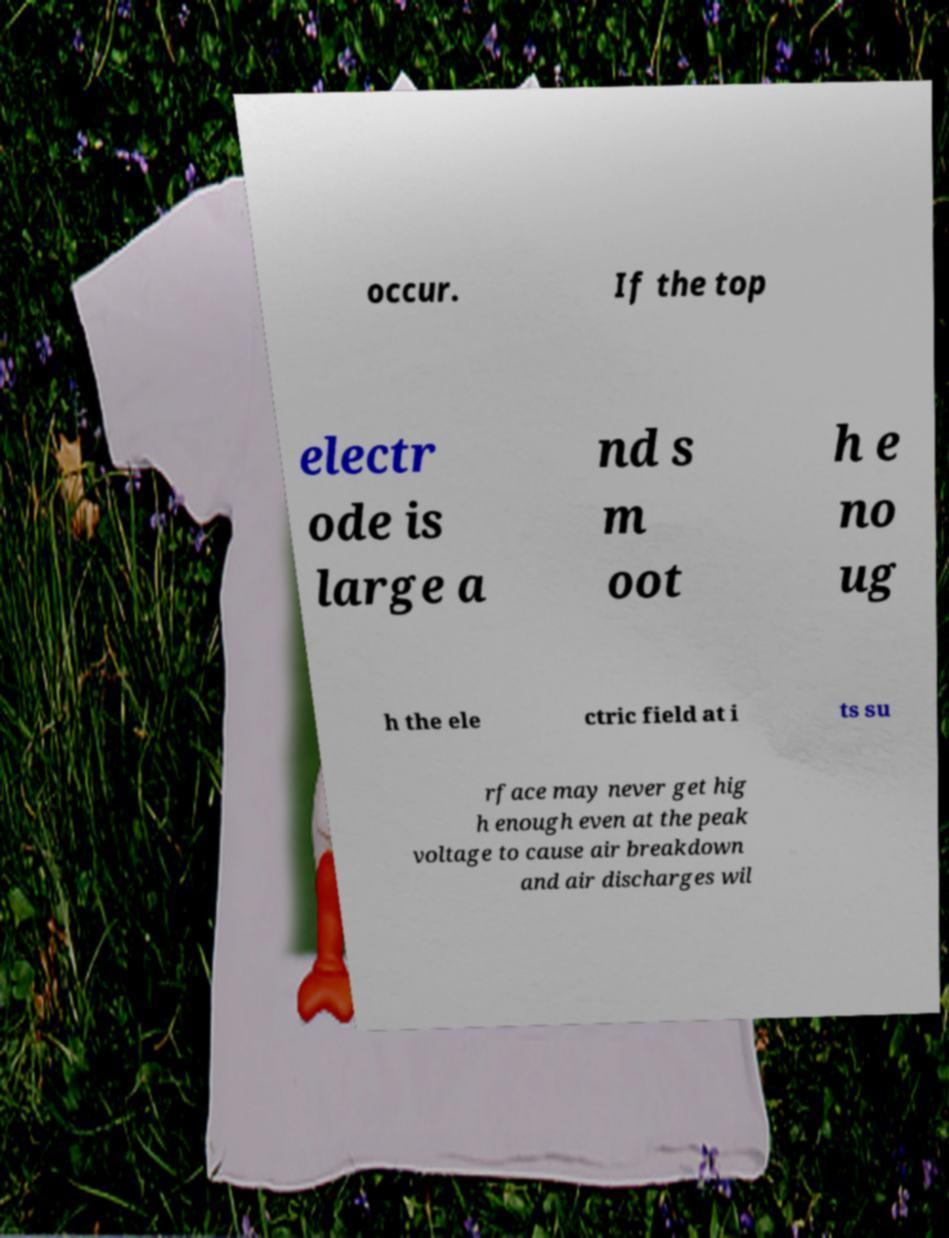Can you read and provide the text displayed in the image?This photo seems to have some interesting text. Can you extract and type it out for me? occur. If the top electr ode is large a nd s m oot h e no ug h the ele ctric field at i ts su rface may never get hig h enough even at the peak voltage to cause air breakdown and air discharges wil 